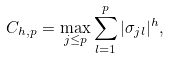<formula> <loc_0><loc_0><loc_500><loc_500>C _ { h , p } = \max _ { j \leq p } \sum _ { l = 1 } ^ { p } | \sigma _ { j l } | ^ { h } ,</formula> 